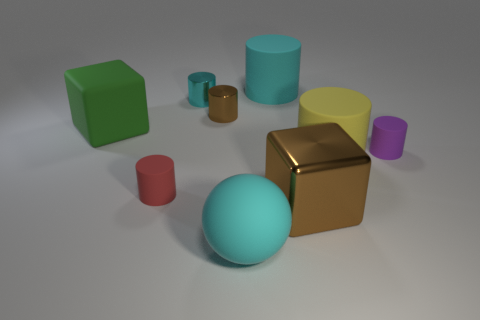What shape is the red thing that is the same size as the purple matte object? cylinder 